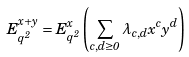<formula> <loc_0><loc_0><loc_500><loc_500>E _ { q ^ { 2 } } ^ { x + y } = E _ { q ^ { 2 } } ^ { x } \left ( \sum _ { c , d \geq 0 } \lambda _ { c , d } x ^ { c } y ^ { d } \right )</formula> 